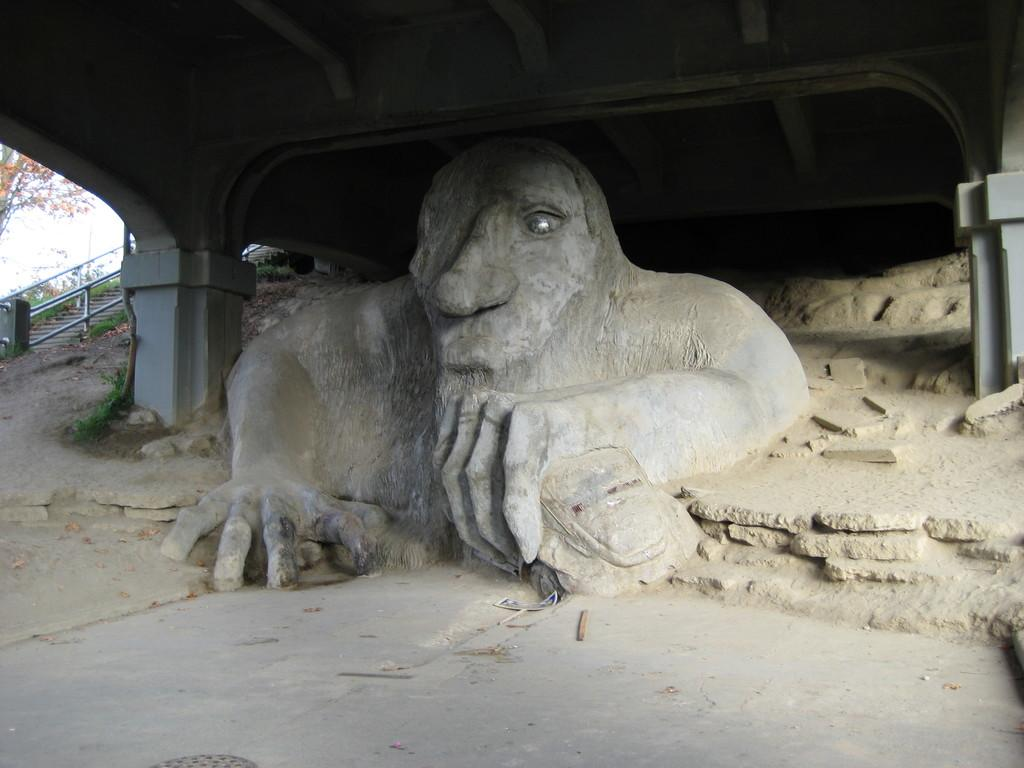What is the main subject of the image? There is a sculpture in the image. Where is the sculpture located? The sculpture is under a shed. What architectural feature can be seen in the image? There are stairs with railing in the image. What type of natural elements are present in the image? There are trees in the image. What is visible in the background of the image? The sky is visible in the image. Can you tell me where the mailbox is located in the image? There is no mailbox present in the image. What type of bun is being used to hold the sculpture in place? There is no bun present in the image, and the sculpture is not being held in place by any bun. 